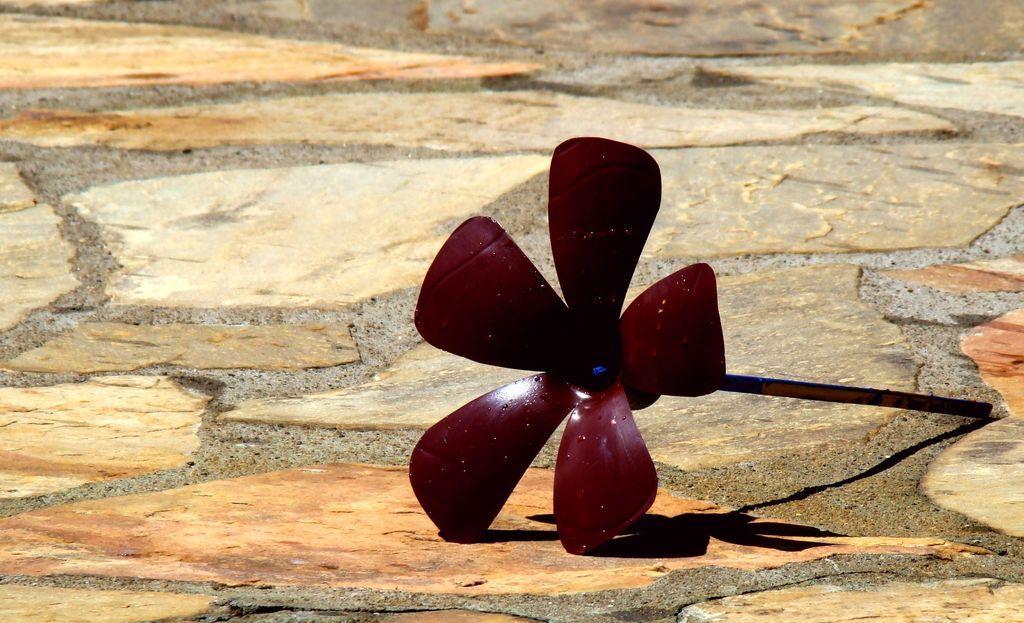Please provide a concise description of this image. In this picture we can observe a maroon color flower shaped object placed on the land. There is a stick connected to this object. In the background there is an open land. 